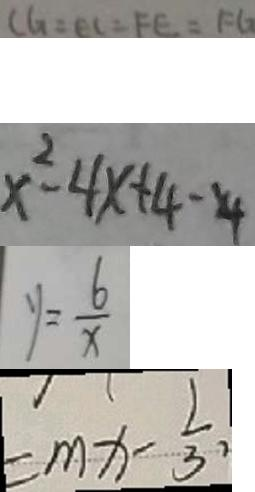<formula> <loc_0><loc_0><loc_500><loc_500>C G = E C = F E = F G 
 x ^ { 2 } - 4 x + 4 - 4 
 y = \frac { 6 } { x } 
 = m x - \frac { 1 } { 3 } ,</formula> 